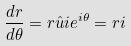<formula> <loc_0><loc_0><loc_500><loc_500>\frac { d r } { d \theta } = r \hat { u } i e ^ { i \theta } = r i</formula> 